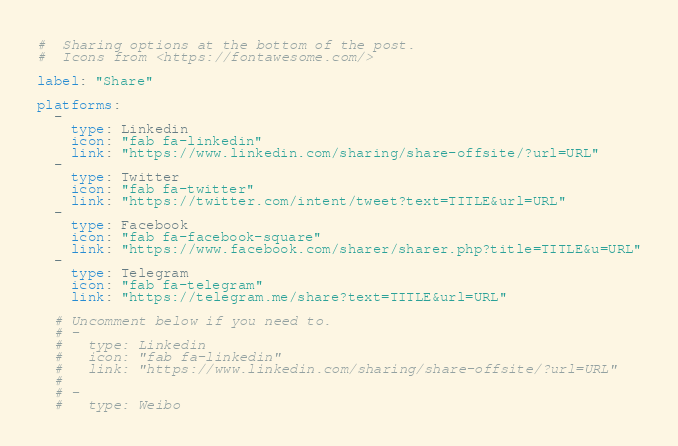<code> <loc_0><loc_0><loc_500><loc_500><_YAML_>#  Sharing options at the bottom of the post.
#  Icons from <https://fontawesome.com/>

label: "Share"

platforms:
  -
    type: Linkedin
    icon: "fab fa-linkedin"
    link: "https://www.linkedin.com/sharing/share-offsite/?url=URL"
  -
    type: Twitter
    icon: "fab fa-twitter"
    link: "https://twitter.com/intent/tweet?text=TITLE&url=URL"
  -
    type: Facebook
    icon: "fab fa-facebook-square"
    link: "https://www.facebook.com/sharer/sharer.php?title=TITLE&u=URL"
  -
    type: Telegram
    icon: "fab fa-telegram"
    link: "https://telegram.me/share?text=TITLE&url=URL"

  # Uncomment below if you need to.
  # -
  #   type: Linkedin
  #   icon: "fab fa-linkedin"
  #   link: "https://www.linkedin.com/sharing/share-offsite/?url=URL"
  #
  # -
  #   type: Weibo</code> 